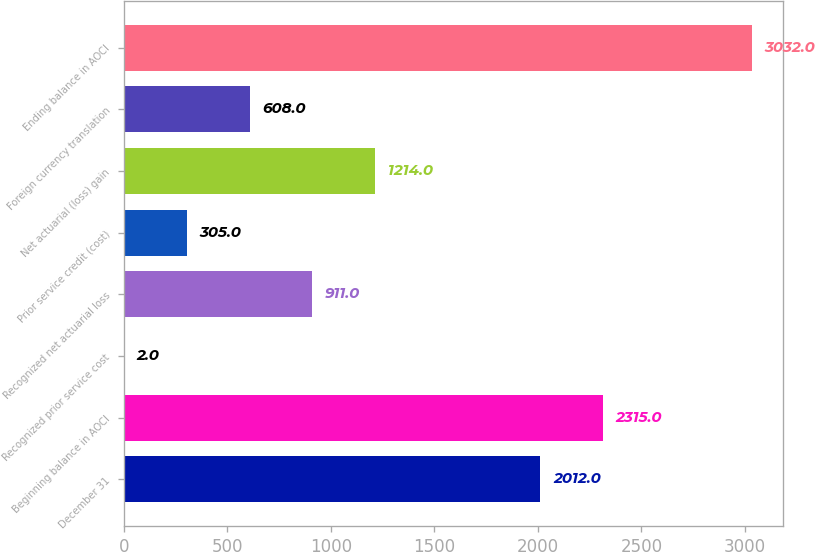Convert chart to OTSL. <chart><loc_0><loc_0><loc_500><loc_500><bar_chart><fcel>December 31<fcel>Beginning balance in AOCI<fcel>Recognized prior service cost<fcel>Recognized net actuarial loss<fcel>Prior service credit (cost)<fcel>Net actuarial (loss) gain<fcel>Foreign currency translation<fcel>Ending balance in AOCI<nl><fcel>2012<fcel>2315<fcel>2<fcel>911<fcel>305<fcel>1214<fcel>608<fcel>3032<nl></chart> 